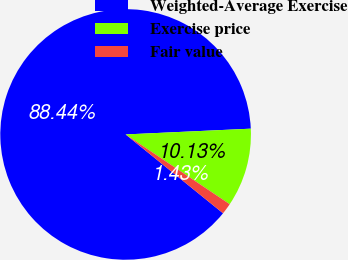Convert chart. <chart><loc_0><loc_0><loc_500><loc_500><pie_chart><fcel>Weighted-Average Exercise<fcel>Exercise price<fcel>Fair value<nl><fcel>88.44%<fcel>10.13%<fcel>1.43%<nl></chart> 